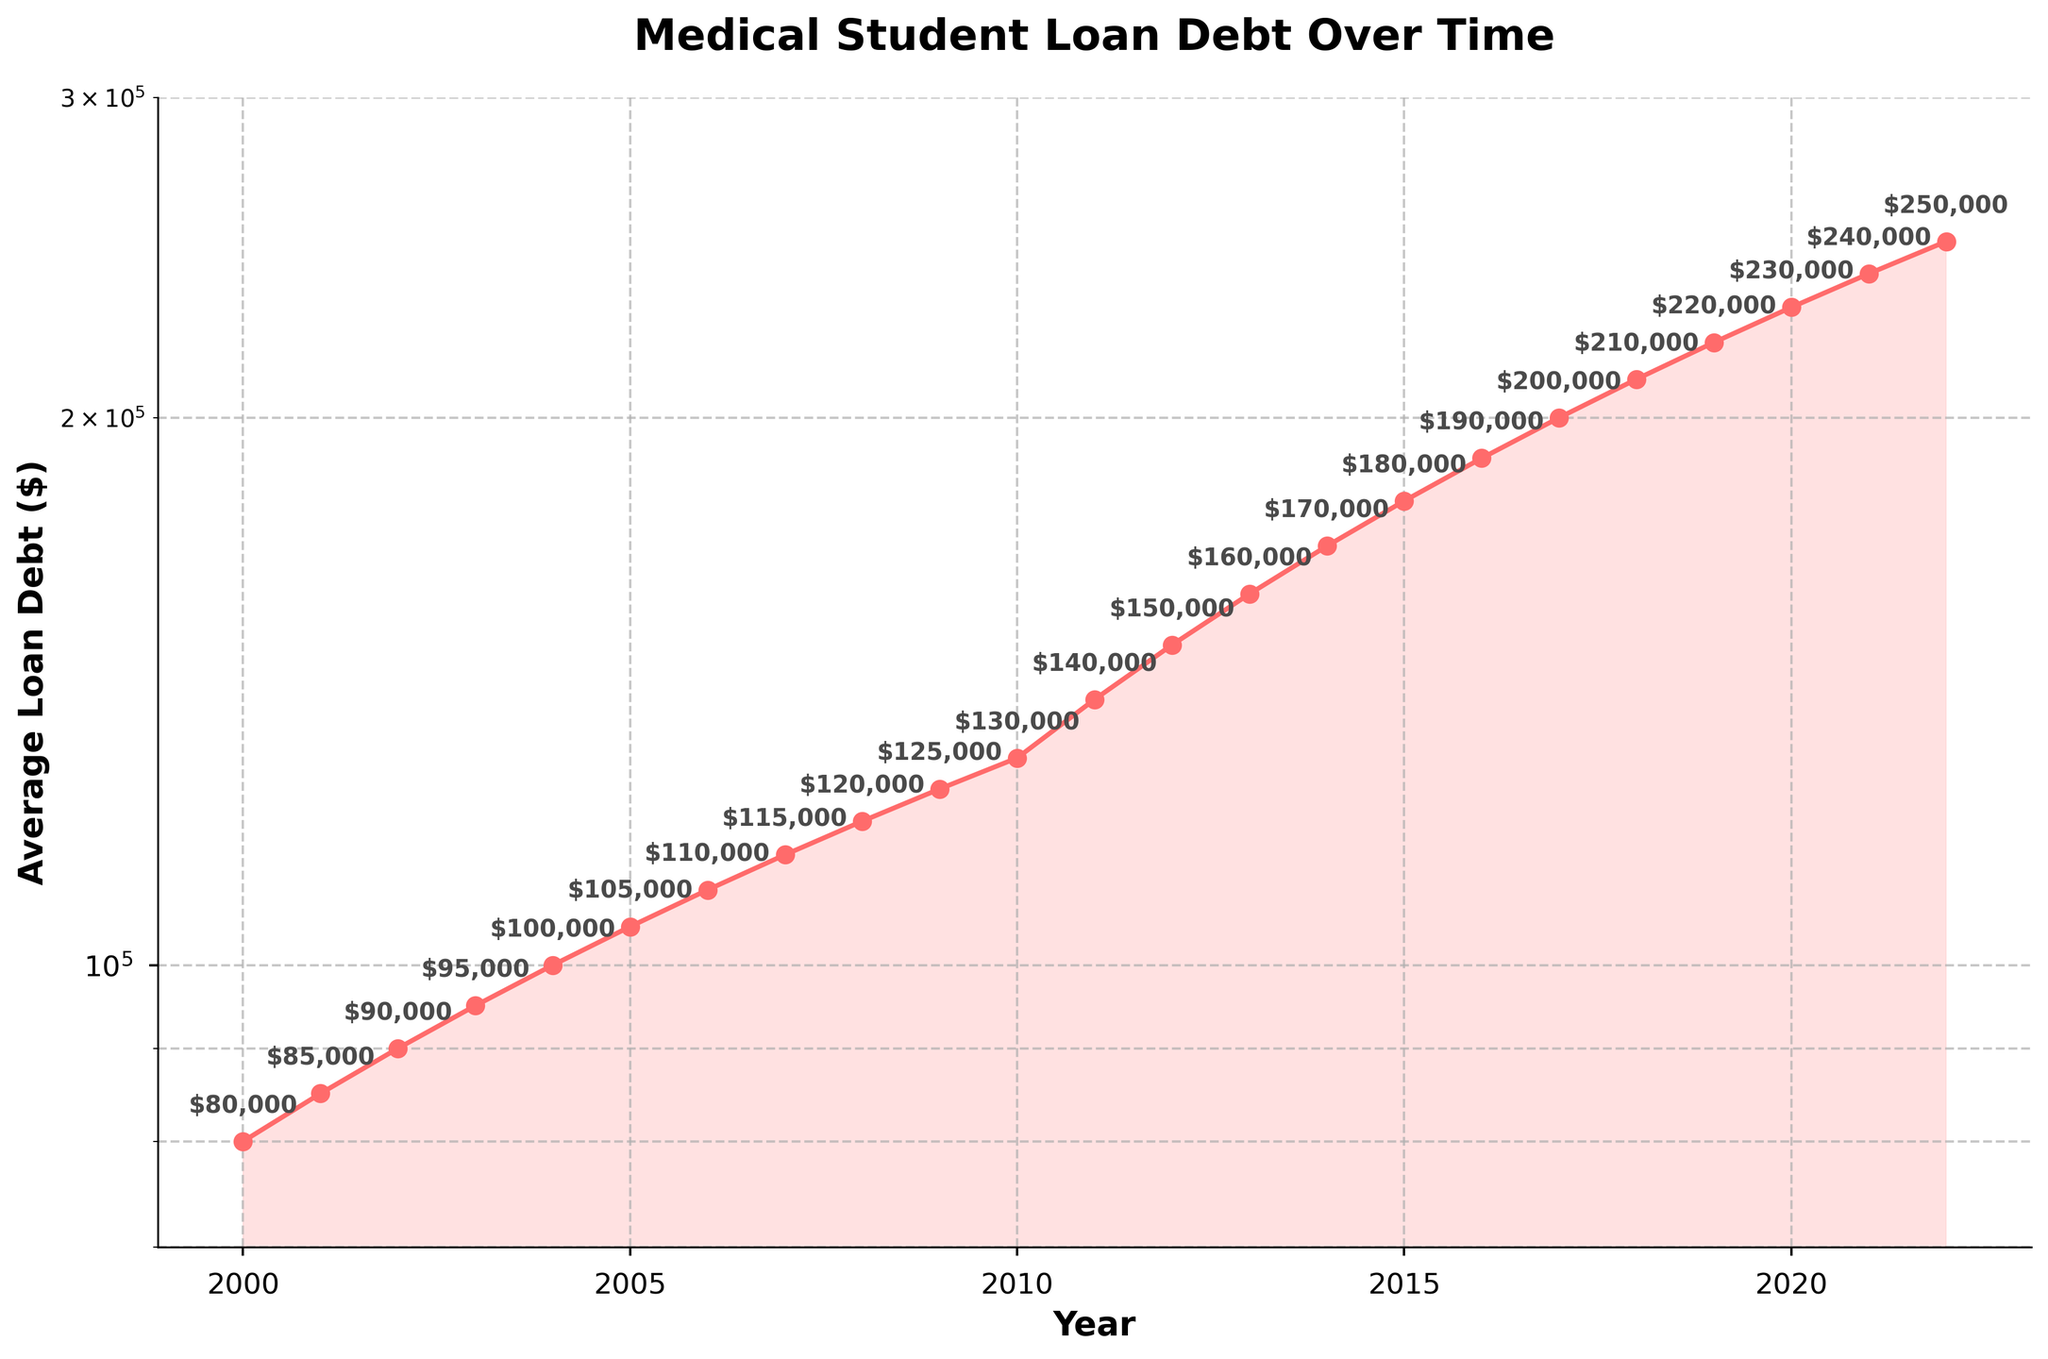which axes are plotted on a log scale? The plot has the y-axis set to a log scale. This is indicated by the label mentioning "Average Loan Debt ($)", and the log scale is apparent from the spacing and increments of the axis values.
Answer: y-axis What is the title of the plot? The title of the plot is displayed at the top and provides a clear summary of what the plot represents.
Answer: Medical Student Loan Debt Over Time What is the average loan debt amount in the year 2000? To find the average loan debt for the year 2000, locate the corresponding point on the line plot for that year and read the annotated value.
Answer: $80,000 How many data points are there in the plot? Count all the distinct points plotted on the line which represent the years from the start date to the end date.
Answer: 23 What is the range of years displayed on the x-axis? Find the earliest and latest year marked along the x-axis to determine the spread of years.
Answer: 2000-2022 In which year did the average loan debt surpass $200,000? Look for the year where the plotted points on the line crossed the horizontal reference line at $200,000.
Answer: 2017 By how much did the average loan debt increase from 2000 to 2022? Calculate the difference between the average loan debt values for these two years by subtracting the 2000 value from the 2022 value.
Answer: $170,000 What trend can be observed in the average loan debt over time? Observe the general direction and pattern of the line plot from left to right to determine if it is generally increasing, decreasing, or stable.
Answer: Increasing Which year had the largest year-over-year increment in average loan debt? Compare the increments between consecutive years and identify the maximum increase.
Answer: 2010-2011 How is the y-axis range determined in this plot? The y-axis range is set based on the minimum and maximum values of the average loan debt, considering the log scale formatting and slightly extending the range for readability. The y-axis is set from $70,000 to $300,000.
Answer: $70,000 to $300,000 